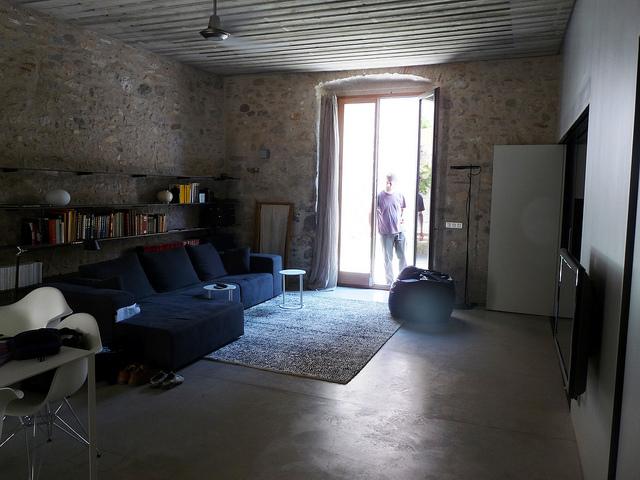Are there any paintings on the wall?
Short answer required. No. Is the man standing at a French style doors?
Short answer required. Yes. Does this room have wall to wall carpeting?
Write a very short answer. No. 